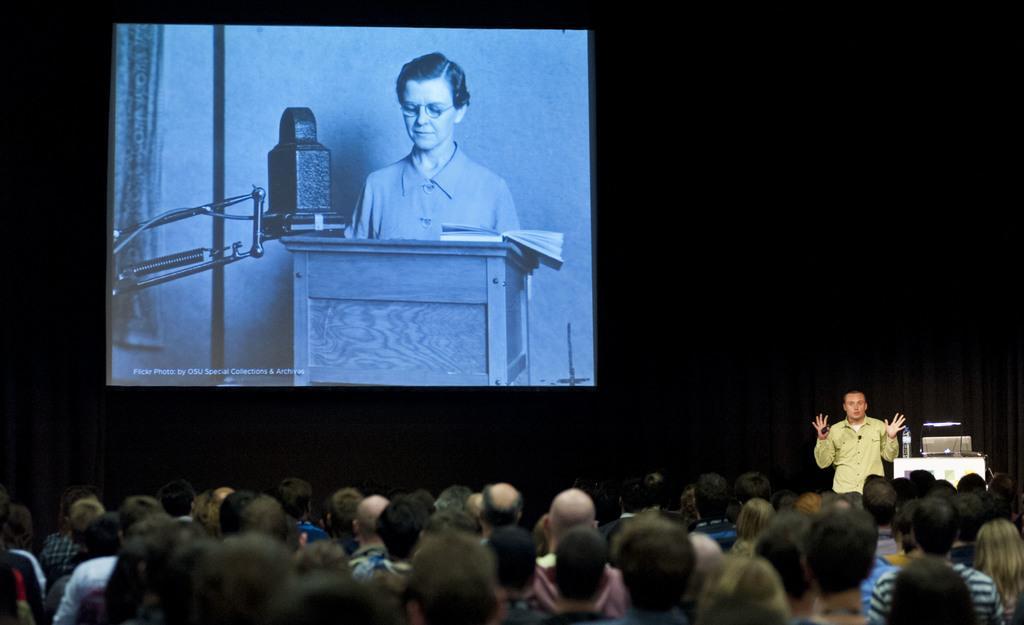Could you give a brief overview of what you see in this image? On the right there is a man who is wearing shirt and holding a mic. He is standing near to the speech desk. On the desk we can see water bottle, laptop and mic. On the top left there is a projector screen. In the projector screen we can see a woman who is standing behind the desk. On the bottom we can see group of persons. 